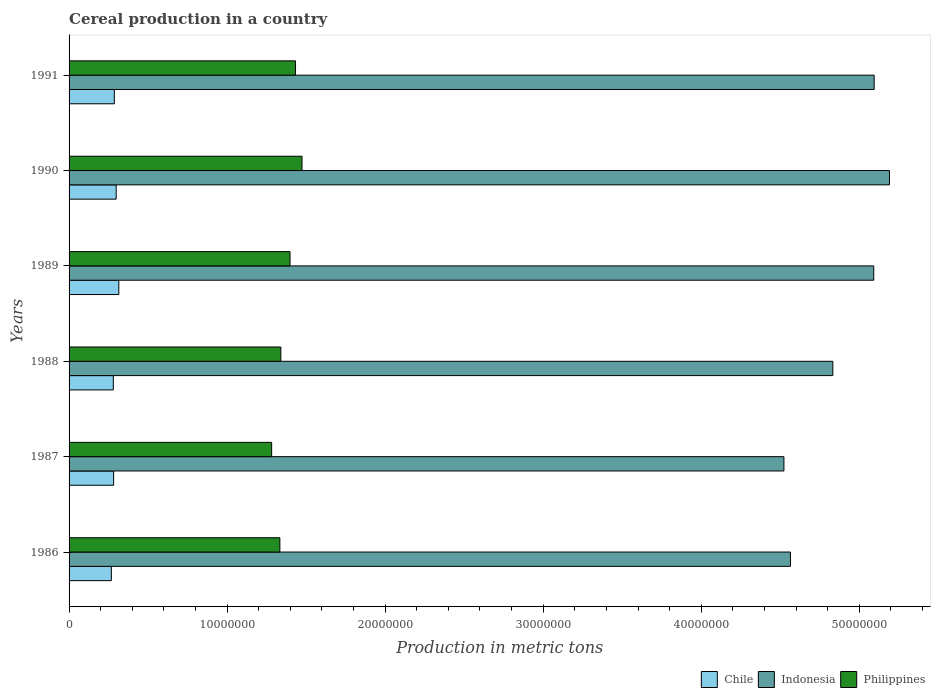Are the number of bars on each tick of the Y-axis equal?
Your answer should be very brief. Yes. How many bars are there on the 1st tick from the top?
Make the answer very short. 3. How many bars are there on the 1st tick from the bottom?
Your answer should be compact. 3. What is the label of the 5th group of bars from the top?
Ensure brevity in your answer.  1987. What is the total cereal production in Chile in 1988?
Your answer should be very brief. 2.80e+06. Across all years, what is the maximum total cereal production in Philippines?
Make the answer very short. 1.47e+07. Across all years, what is the minimum total cereal production in Philippines?
Offer a terse response. 1.28e+07. In which year was the total cereal production in Indonesia maximum?
Give a very brief answer. 1990. In which year was the total cereal production in Chile minimum?
Make the answer very short. 1986. What is the total total cereal production in Philippines in the graph?
Your response must be concise. 8.26e+07. What is the difference between the total cereal production in Indonesia in 1986 and that in 1990?
Your answer should be very brief. -6.27e+06. What is the difference between the total cereal production in Indonesia in 1987 and the total cereal production in Philippines in 1988?
Your answer should be compact. 3.18e+07. What is the average total cereal production in Philippines per year?
Offer a terse response. 1.38e+07. In the year 1990, what is the difference between the total cereal production in Chile and total cereal production in Philippines?
Provide a succinct answer. -1.18e+07. What is the ratio of the total cereal production in Chile in 1987 to that in 1989?
Offer a very short reply. 0.9. Is the difference between the total cereal production in Chile in 1986 and 1991 greater than the difference between the total cereal production in Philippines in 1986 and 1991?
Ensure brevity in your answer.  Yes. What is the difference between the highest and the second highest total cereal production in Philippines?
Provide a succinct answer. 4.11e+05. What is the difference between the highest and the lowest total cereal production in Chile?
Give a very brief answer. 4.73e+05. Is the sum of the total cereal production in Philippines in 1986 and 1990 greater than the maximum total cereal production in Indonesia across all years?
Your answer should be compact. No. What does the 3rd bar from the top in 1991 represents?
Your answer should be very brief. Chile. What does the 1st bar from the bottom in 1987 represents?
Your answer should be compact. Chile. How many bars are there?
Provide a succinct answer. 18. Are all the bars in the graph horizontal?
Keep it short and to the point. Yes. How many years are there in the graph?
Your answer should be very brief. 6. Where does the legend appear in the graph?
Offer a very short reply. Bottom right. How are the legend labels stacked?
Provide a succinct answer. Horizontal. What is the title of the graph?
Your answer should be compact. Cereal production in a country. What is the label or title of the X-axis?
Your response must be concise. Production in metric tons. What is the label or title of the Y-axis?
Your answer should be compact. Years. What is the Production in metric tons in Chile in 1986?
Your answer should be very brief. 2.67e+06. What is the Production in metric tons in Indonesia in 1986?
Your response must be concise. 4.56e+07. What is the Production in metric tons of Philippines in 1986?
Ensure brevity in your answer.  1.33e+07. What is the Production in metric tons of Chile in 1987?
Ensure brevity in your answer.  2.82e+06. What is the Production in metric tons of Indonesia in 1987?
Your answer should be very brief. 4.52e+07. What is the Production in metric tons of Philippines in 1987?
Ensure brevity in your answer.  1.28e+07. What is the Production in metric tons in Chile in 1988?
Your answer should be compact. 2.80e+06. What is the Production in metric tons of Indonesia in 1988?
Your answer should be very brief. 4.83e+07. What is the Production in metric tons of Philippines in 1988?
Your response must be concise. 1.34e+07. What is the Production in metric tons of Chile in 1989?
Keep it short and to the point. 3.15e+06. What is the Production in metric tons in Indonesia in 1989?
Your answer should be very brief. 5.09e+07. What is the Production in metric tons of Philippines in 1989?
Make the answer very short. 1.40e+07. What is the Production in metric tons in Chile in 1990?
Your answer should be very brief. 2.98e+06. What is the Production in metric tons in Indonesia in 1990?
Offer a very short reply. 5.19e+07. What is the Production in metric tons of Philippines in 1990?
Make the answer very short. 1.47e+07. What is the Production in metric tons of Chile in 1991?
Make the answer very short. 2.86e+06. What is the Production in metric tons in Indonesia in 1991?
Offer a terse response. 5.09e+07. What is the Production in metric tons in Philippines in 1991?
Offer a terse response. 1.43e+07. Across all years, what is the maximum Production in metric tons in Chile?
Your response must be concise. 3.15e+06. Across all years, what is the maximum Production in metric tons in Indonesia?
Give a very brief answer. 5.19e+07. Across all years, what is the maximum Production in metric tons of Philippines?
Provide a succinct answer. 1.47e+07. Across all years, what is the minimum Production in metric tons in Chile?
Offer a terse response. 2.67e+06. Across all years, what is the minimum Production in metric tons in Indonesia?
Make the answer very short. 4.52e+07. Across all years, what is the minimum Production in metric tons in Philippines?
Offer a very short reply. 1.28e+07. What is the total Production in metric tons in Chile in the graph?
Offer a very short reply. 1.73e+07. What is the total Production in metric tons of Indonesia in the graph?
Offer a very short reply. 2.93e+08. What is the total Production in metric tons in Philippines in the graph?
Offer a very short reply. 8.26e+07. What is the difference between the Production in metric tons of Chile in 1986 and that in 1987?
Your response must be concise. -1.44e+05. What is the difference between the Production in metric tons of Indonesia in 1986 and that in 1987?
Make the answer very short. 4.13e+05. What is the difference between the Production in metric tons of Philippines in 1986 and that in 1987?
Ensure brevity in your answer.  5.20e+05. What is the difference between the Production in metric tons in Chile in 1986 and that in 1988?
Give a very brief answer. -1.25e+05. What is the difference between the Production in metric tons in Indonesia in 1986 and that in 1988?
Your answer should be compact. -2.68e+06. What is the difference between the Production in metric tons of Philippines in 1986 and that in 1988?
Offer a very short reply. -6.12e+04. What is the difference between the Production in metric tons of Chile in 1986 and that in 1989?
Keep it short and to the point. -4.73e+05. What is the difference between the Production in metric tons of Indonesia in 1986 and that in 1989?
Your answer should be compact. -5.27e+06. What is the difference between the Production in metric tons of Philippines in 1986 and that in 1989?
Ensure brevity in your answer.  -6.43e+05. What is the difference between the Production in metric tons in Chile in 1986 and that in 1990?
Offer a terse response. -3.06e+05. What is the difference between the Production in metric tons of Indonesia in 1986 and that in 1990?
Ensure brevity in your answer.  -6.27e+06. What is the difference between the Production in metric tons of Philippines in 1986 and that in 1990?
Your answer should be compact. -1.40e+06. What is the difference between the Production in metric tons of Chile in 1986 and that in 1991?
Your answer should be very brief. -1.89e+05. What is the difference between the Production in metric tons of Indonesia in 1986 and that in 1991?
Your answer should be very brief. -5.30e+06. What is the difference between the Production in metric tons in Philippines in 1986 and that in 1991?
Offer a terse response. -9.91e+05. What is the difference between the Production in metric tons in Chile in 1987 and that in 1988?
Keep it short and to the point. 1.95e+04. What is the difference between the Production in metric tons of Indonesia in 1987 and that in 1988?
Make the answer very short. -3.09e+06. What is the difference between the Production in metric tons of Philippines in 1987 and that in 1988?
Ensure brevity in your answer.  -5.81e+05. What is the difference between the Production in metric tons of Chile in 1987 and that in 1989?
Keep it short and to the point. -3.29e+05. What is the difference between the Production in metric tons of Indonesia in 1987 and that in 1989?
Your answer should be very brief. -5.68e+06. What is the difference between the Production in metric tons of Philippines in 1987 and that in 1989?
Offer a very short reply. -1.16e+06. What is the difference between the Production in metric tons in Chile in 1987 and that in 1990?
Give a very brief answer. -1.62e+05. What is the difference between the Production in metric tons in Indonesia in 1987 and that in 1990?
Give a very brief answer. -6.68e+06. What is the difference between the Production in metric tons in Philippines in 1987 and that in 1990?
Give a very brief answer. -1.92e+06. What is the difference between the Production in metric tons of Chile in 1987 and that in 1991?
Your answer should be compact. -4.48e+04. What is the difference between the Production in metric tons in Indonesia in 1987 and that in 1991?
Ensure brevity in your answer.  -5.71e+06. What is the difference between the Production in metric tons of Philippines in 1987 and that in 1991?
Provide a short and direct response. -1.51e+06. What is the difference between the Production in metric tons in Chile in 1988 and that in 1989?
Your response must be concise. -3.48e+05. What is the difference between the Production in metric tons in Indonesia in 1988 and that in 1989?
Make the answer very short. -2.59e+06. What is the difference between the Production in metric tons in Philippines in 1988 and that in 1989?
Your response must be concise. -5.82e+05. What is the difference between the Production in metric tons in Chile in 1988 and that in 1990?
Offer a terse response. -1.81e+05. What is the difference between the Production in metric tons of Indonesia in 1988 and that in 1990?
Your answer should be compact. -3.58e+06. What is the difference between the Production in metric tons of Philippines in 1988 and that in 1990?
Ensure brevity in your answer.  -1.34e+06. What is the difference between the Production in metric tons of Chile in 1988 and that in 1991?
Give a very brief answer. -6.43e+04. What is the difference between the Production in metric tons of Indonesia in 1988 and that in 1991?
Make the answer very short. -2.62e+06. What is the difference between the Production in metric tons of Philippines in 1988 and that in 1991?
Your response must be concise. -9.29e+05. What is the difference between the Production in metric tons of Chile in 1989 and that in 1990?
Your answer should be compact. 1.67e+05. What is the difference between the Production in metric tons of Indonesia in 1989 and that in 1990?
Offer a very short reply. -9.95e+05. What is the difference between the Production in metric tons of Philippines in 1989 and that in 1990?
Provide a short and direct response. -7.58e+05. What is the difference between the Production in metric tons of Chile in 1989 and that in 1991?
Your answer should be compact. 2.84e+05. What is the difference between the Production in metric tons in Indonesia in 1989 and that in 1991?
Your answer should be compact. -2.60e+04. What is the difference between the Production in metric tons in Philippines in 1989 and that in 1991?
Provide a succinct answer. -3.47e+05. What is the difference between the Production in metric tons of Chile in 1990 and that in 1991?
Offer a very short reply. 1.17e+05. What is the difference between the Production in metric tons in Indonesia in 1990 and that in 1991?
Your answer should be compact. 9.69e+05. What is the difference between the Production in metric tons in Philippines in 1990 and that in 1991?
Provide a succinct answer. 4.11e+05. What is the difference between the Production in metric tons of Chile in 1986 and the Production in metric tons of Indonesia in 1987?
Ensure brevity in your answer.  -4.26e+07. What is the difference between the Production in metric tons of Chile in 1986 and the Production in metric tons of Philippines in 1987?
Your answer should be compact. -1.01e+07. What is the difference between the Production in metric tons in Indonesia in 1986 and the Production in metric tons in Philippines in 1987?
Offer a terse response. 3.28e+07. What is the difference between the Production in metric tons of Chile in 1986 and the Production in metric tons of Indonesia in 1988?
Your answer should be very brief. -4.57e+07. What is the difference between the Production in metric tons in Chile in 1986 and the Production in metric tons in Philippines in 1988?
Offer a very short reply. -1.07e+07. What is the difference between the Production in metric tons of Indonesia in 1986 and the Production in metric tons of Philippines in 1988?
Your answer should be compact. 3.22e+07. What is the difference between the Production in metric tons of Chile in 1986 and the Production in metric tons of Indonesia in 1989?
Give a very brief answer. -4.82e+07. What is the difference between the Production in metric tons in Chile in 1986 and the Production in metric tons in Philippines in 1989?
Make the answer very short. -1.13e+07. What is the difference between the Production in metric tons in Indonesia in 1986 and the Production in metric tons in Philippines in 1989?
Keep it short and to the point. 3.17e+07. What is the difference between the Production in metric tons in Chile in 1986 and the Production in metric tons in Indonesia in 1990?
Offer a terse response. -4.92e+07. What is the difference between the Production in metric tons of Chile in 1986 and the Production in metric tons of Philippines in 1990?
Your answer should be compact. -1.21e+07. What is the difference between the Production in metric tons of Indonesia in 1986 and the Production in metric tons of Philippines in 1990?
Make the answer very short. 3.09e+07. What is the difference between the Production in metric tons of Chile in 1986 and the Production in metric tons of Indonesia in 1991?
Your response must be concise. -4.83e+07. What is the difference between the Production in metric tons in Chile in 1986 and the Production in metric tons in Philippines in 1991?
Your answer should be compact. -1.17e+07. What is the difference between the Production in metric tons in Indonesia in 1986 and the Production in metric tons in Philippines in 1991?
Give a very brief answer. 3.13e+07. What is the difference between the Production in metric tons of Chile in 1987 and the Production in metric tons of Indonesia in 1988?
Offer a very short reply. -4.55e+07. What is the difference between the Production in metric tons of Chile in 1987 and the Production in metric tons of Philippines in 1988?
Provide a succinct answer. -1.06e+07. What is the difference between the Production in metric tons in Indonesia in 1987 and the Production in metric tons in Philippines in 1988?
Keep it short and to the point. 3.18e+07. What is the difference between the Production in metric tons of Chile in 1987 and the Production in metric tons of Indonesia in 1989?
Make the answer very short. -4.81e+07. What is the difference between the Production in metric tons of Chile in 1987 and the Production in metric tons of Philippines in 1989?
Make the answer very short. -1.12e+07. What is the difference between the Production in metric tons of Indonesia in 1987 and the Production in metric tons of Philippines in 1989?
Keep it short and to the point. 3.13e+07. What is the difference between the Production in metric tons of Chile in 1987 and the Production in metric tons of Indonesia in 1990?
Ensure brevity in your answer.  -4.91e+07. What is the difference between the Production in metric tons in Chile in 1987 and the Production in metric tons in Philippines in 1990?
Keep it short and to the point. -1.19e+07. What is the difference between the Production in metric tons in Indonesia in 1987 and the Production in metric tons in Philippines in 1990?
Give a very brief answer. 3.05e+07. What is the difference between the Production in metric tons of Chile in 1987 and the Production in metric tons of Indonesia in 1991?
Ensure brevity in your answer.  -4.81e+07. What is the difference between the Production in metric tons of Chile in 1987 and the Production in metric tons of Philippines in 1991?
Ensure brevity in your answer.  -1.15e+07. What is the difference between the Production in metric tons of Indonesia in 1987 and the Production in metric tons of Philippines in 1991?
Keep it short and to the point. 3.09e+07. What is the difference between the Production in metric tons of Chile in 1988 and the Production in metric tons of Indonesia in 1989?
Ensure brevity in your answer.  -4.81e+07. What is the difference between the Production in metric tons of Chile in 1988 and the Production in metric tons of Philippines in 1989?
Your response must be concise. -1.12e+07. What is the difference between the Production in metric tons of Indonesia in 1988 and the Production in metric tons of Philippines in 1989?
Offer a terse response. 3.43e+07. What is the difference between the Production in metric tons of Chile in 1988 and the Production in metric tons of Indonesia in 1990?
Provide a short and direct response. -4.91e+07. What is the difference between the Production in metric tons in Chile in 1988 and the Production in metric tons in Philippines in 1990?
Give a very brief answer. -1.19e+07. What is the difference between the Production in metric tons in Indonesia in 1988 and the Production in metric tons in Philippines in 1990?
Your response must be concise. 3.36e+07. What is the difference between the Production in metric tons in Chile in 1988 and the Production in metric tons in Indonesia in 1991?
Give a very brief answer. -4.81e+07. What is the difference between the Production in metric tons in Chile in 1988 and the Production in metric tons in Philippines in 1991?
Your answer should be compact. -1.15e+07. What is the difference between the Production in metric tons in Indonesia in 1988 and the Production in metric tons in Philippines in 1991?
Your answer should be very brief. 3.40e+07. What is the difference between the Production in metric tons in Chile in 1989 and the Production in metric tons in Indonesia in 1990?
Keep it short and to the point. -4.88e+07. What is the difference between the Production in metric tons of Chile in 1989 and the Production in metric tons of Philippines in 1990?
Your response must be concise. -1.16e+07. What is the difference between the Production in metric tons of Indonesia in 1989 and the Production in metric tons of Philippines in 1990?
Keep it short and to the point. 3.62e+07. What is the difference between the Production in metric tons in Chile in 1989 and the Production in metric tons in Indonesia in 1991?
Keep it short and to the point. -4.78e+07. What is the difference between the Production in metric tons of Chile in 1989 and the Production in metric tons of Philippines in 1991?
Your answer should be compact. -1.12e+07. What is the difference between the Production in metric tons in Indonesia in 1989 and the Production in metric tons in Philippines in 1991?
Make the answer very short. 3.66e+07. What is the difference between the Production in metric tons in Chile in 1990 and the Production in metric tons in Indonesia in 1991?
Your response must be concise. -4.80e+07. What is the difference between the Production in metric tons of Chile in 1990 and the Production in metric tons of Philippines in 1991?
Make the answer very short. -1.13e+07. What is the difference between the Production in metric tons of Indonesia in 1990 and the Production in metric tons of Philippines in 1991?
Provide a short and direct response. 3.76e+07. What is the average Production in metric tons in Chile per year?
Your answer should be very brief. 2.88e+06. What is the average Production in metric tons in Indonesia per year?
Provide a succinct answer. 4.88e+07. What is the average Production in metric tons in Philippines per year?
Keep it short and to the point. 1.38e+07. In the year 1986, what is the difference between the Production in metric tons in Chile and Production in metric tons in Indonesia?
Make the answer very short. -4.30e+07. In the year 1986, what is the difference between the Production in metric tons in Chile and Production in metric tons in Philippines?
Ensure brevity in your answer.  -1.07e+07. In the year 1986, what is the difference between the Production in metric tons in Indonesia and Production in metric tons in Philippines?
Provide a short and direct response. 3.23e+07. In the year 1987, what is the difference between the Production in metric tons of Chile and Production in metric tons of Indonesia?
Ensure brevity in your answer.  -4.24e+07. In the year 1987, what is the difference between the Production in metric tons in Chile and Production in metric tons in Philippines?
Offer a terse response. -1.00e+07. In the year 1987, what is the difference between the Production in metric tons of Indonesia and Production in metric tons of Philippines?
Your answer should be compact. 3.24e+07. In the year 1988, what is the difference between the Production in metric tons of Chile and Production in metric tons of Indonesia?
Offer a terse response. -4.55e+07. In the year 1988, what is the difference between the Production in metric tons of Chile and Production in metric tons of Philippines?
Give a very brief answer. -1.06e+07. In the year 1988, what is the difference between the Production in metric tons in Indonesia and Production in metric tons in Philippines?
Ensure brevity in your answer.  3.49e+07. In the year 1989, what is the difference between the Production in metric tons in Chile and Production in metric tons in Indonesia?
Your response must be concise. -4.78e+07. In the year 1989, what is the difference between the Production in metric tons in Chile and Production in metric tons in Philippines?
Give a very brief answer. -1.08e+07. In the year 1989, what is the difference between the Production in metric tons in Indonesia and Production in metric tons in Philippines?
Your answer should be compact. 3.69e+07. In the year 1990, what is the difference between the Production in metric tons in Chile and Production in metric tons in Indonesia?
Your answer should be compact. -4.89e+07. In the year 1990, what is the difference between the Production in metric tons of Chile and Production in metric tons of Philippines?
Make the answer very short. -1.18e+07. In the year 1990, what is the difference between the Production in metric tons of Indonesia and Production in metric tons of Philippines?
Your response must be concise. 3.72e+07. In the year 1991, what is the difference between the Production in metric tons of Chile and Production in metric tons of Indonesia?
Keep it short and to the point. -4.81e+07. In the year 1991, what is the difference between the Production in metric tons of Chile and Production in metric tons of Philippines?
Keep it short and to the point. -1.15e+07. In the year 1991, what is the difference between the Production in metric tons of Indonesia and Production in metric tons of Philippines?
Ensure brevity in your answer.  3.66e+07. What is the ratio of the Production in metric tons in Chile in 1986 to that in 1987?
Ensure brevity in your answer.  0.95. What is the ratio of the Production in metric tons of Indonesia in 1986 to that in 1987?
Your answer should be very brief. 1.01. What is the ratio of the Production in metric tons in Philippines in 1986 to that in 1987?
Your answer should be compact. 1.04. What is the ratio of the Production in metric tons of Chile in 1986 to that in 1988?
Provide a short and direct response. 0.96. What is the ratio of the Production in metric tons in Indonesia in 1986 to that in 1988?
Provide a short and direct response. 0.94. What is the ratio of the Production in metric tons in Philippines in 1986 to that in 1988?
Give a very brief answer. 1. What is the ratio of the Production in metric tons of Chile in 1986 to that in 1989?
Ensure brevity in your answer.  0.85. What is the ratio of the Production in metric tons of Indonesia in 1986 to that in 1989?
Keep it short and to the point. 0.9. What is the ratio of the Production in metric tons in Philippines in 1986 to that in 1989?
Your response must be concise. 0.95. What is the ratio of the Production in metric tons in Chile in 1986 to that in 1990?
Provide a short and direct response. 0.9. What is the ratio of the Production in metric tons of Indonesia in 1986 to that in 1990?
Provide a succinct answer. 0.88. What is the ratio of the Production in metric tons in Philippines in 1986 to that in 1990?
Keep it short and to the point. 0.9. What is the ratio of the Production in metric tons of Chile in 1986 to that in 1991?
Offer a very short reply. 0.93. What is the ratio of the Production in metric tons in Indonesia in 1986 to that in 1991?
Offer a very short reply. 0.9. What is the ratio of the Production in metric tons in Philippines in 1986 to that in 1991?
Keep it short and to the point. 0.93. What is the ratio of the Production in metric tons in Chile in 1987 to that in 1988?
Your response must be concise. 1.01. What is the ratio of the Production in metric tons in Indonesia in 1987 to that in 1988?
Make the answer very short. 0.94. What is the ratio of the Production in metric tons of Philippines in 1987 to that in 1988?
Your answer should be very brief. 0.96. What is the ratio of the Production in metric tons in Chile in 1987 to that in 1989?
Your answer should be compact. 0.9. What is the ratio of the Production in metric tons in Indonesia in 1987 to that in 1989?
Make the answer very short. 0.89. What is the ratio of the Production in metric tons of Philippines in 1987 to that in 1989?
Provide a short and direct response. 0.92. What is the ratio of the Production in metric tons of Chile in 1987 to that in 1990?
Your answer should be compact. 0.95. What is the ratio of the Production in metric tons in Indonesia in 1987 to that in 1990?
Ensure brevity in your answer.  0.87. What is the ratio of the Production in metric tons of Philippines in 1987 to that in 1990?
Make the answer very short. 0.87. What is the ratio of the Production in metric tons in Chile in 1987 to that in 1991?
Your response must be concise. 0.98. What is the ratio of the Production in metric tons of Indonesia in 1987 to that in 1991?
Your answer should be compact. 0.89. What is the ratio of the Production in metric tons in Philippines in 1987 to that in 1991?
Your answer should be compact. 0.89. What is the ratio of the Production in metric tons of Chile in 1988 to that in 1989?
Your answer should be compact. 0.89. What is the ratio of the Production in metric tons in Indonesia in 1988 to that in 1989?
Ensure brevity in your answer.  0.95. What is the ratio of the Production in metric tons in Philippines in 1988 to that in 1989?
Provide a short and direct response. 0.96. What is the ratio of the Production in metric tons of Chile in 1988 to that in 1990?
Your answer should be compact. 0.94. What is the ratio of the Production in metric tons in Indonesia in 1988 to that in 1990?
Provide a short and direct response. 0.93. What is the ratio of the Production in metric tons in Philippines in 1988 to that in 1990?
Your response must be concise. 0.91. What is the ratio of the Production in metric tons in Chile in 1988 to that in 1991?
Offer a terse response. 0.98. What is the ratio of the Production in metric tons in Indonesia in 1988 to that in 1991?
Your answer should be very brief. 0.95. What is the ratio of the Production in metric tons of Philippines in 1988 to that in 1991?
Offer a very short reply. 0.94. What is the ratio of the Production in metric tons of Chile in 1989 to that in 1990?
Your answer should be very brief. 1.06. What is the ratio of the Production in metric tons in Indonesia in 1989 to that in 1990?
Make the answer very short. 0.98. What is the ratio of the Production in metric tons of Philippines in 1989 to that in 1990?
Offer a terse response. 0.95. What is the ratio of the Production in metric tons of Chile in 1989 to that in 1991?
Offer a terse response. 1.1. What is the ratio of the Production in metric tons in Indonesia in 1989 to that in 1991?
Offer a very short reply. 1. What is the ratio of the Production in metric tons of Philippines in 1989 to that in 1991?
Provide a succinct answer. 0.98. What is the ratio of the Production in metric tons of Chile in 1990 to that in 1991?
Provide a succinct answer. 1.04. What is the ratio of the Production in metric tons in Indonesia in 1990 to that in 1991?
Your response must be concise. 1.02. What is the ratio of the Production in metric tons of Philippines in 1990 to that in 1991?
Your answer should be very brief. 1.03. What is the difference between the highest and the second highest Production in metric tons in Chile?
Offer a very short reply. 1.67e+05. What is the difference between the highest and the second highest Production in metric tons of Indonesia?
Your answer should be very brief. 9.69e+05. What is the difference between the highest and the second highest Production in metric tons of Philippines?
Your answer should be very brief. 4.11e+05. What is the difference between the highest and the lowest Production in metric tons of Chile?
Your answer should be compact. 4.73e+05. What is the difference between the highest and the lowest Production in metric tons of Indonesia?
Offer a terse response. 6.68e+06. What is the difference between the highest and the lowest Production in metric tons in Philippines?
Provide a short and direct response. 1.92e+06. 